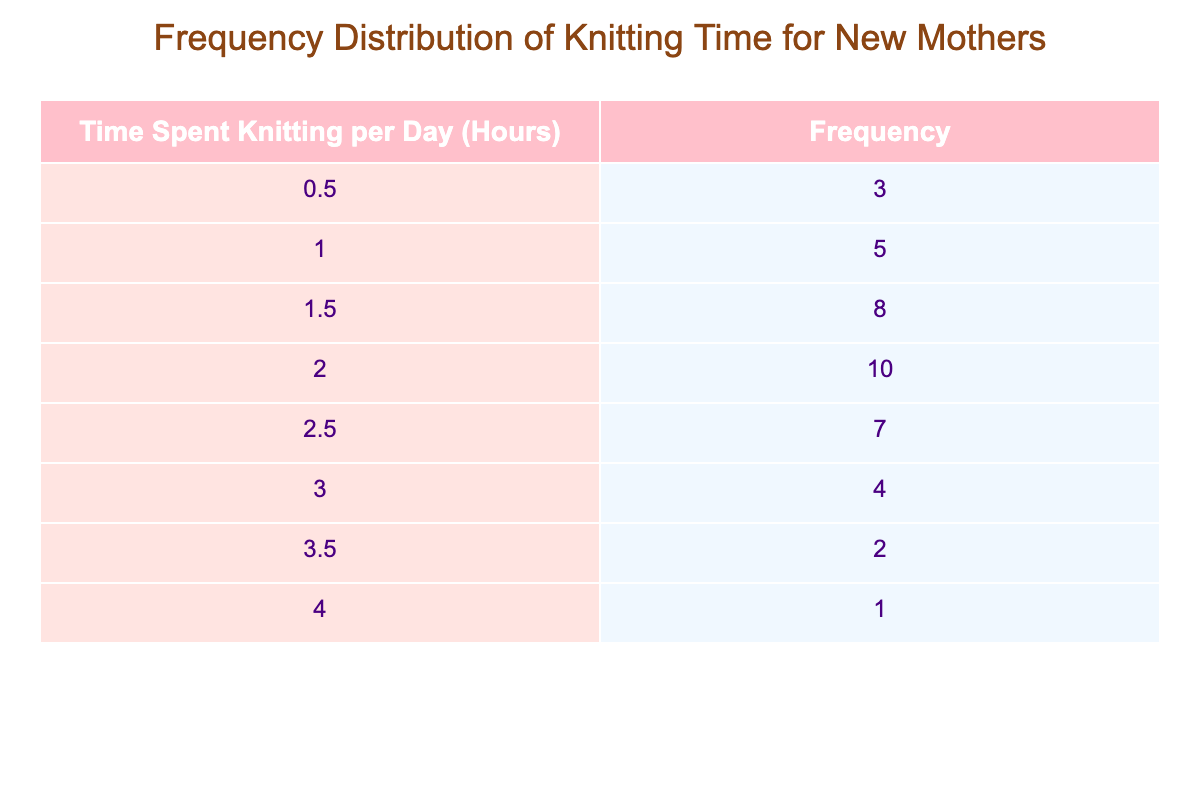What is the frequency of new mothers who spend 1 hour knitting each day? The table indicates that the frequency for 1 hour spent knitting per day is 5.
Answer: 5 How many new mothers spend less than 2 hours knitting per day? To find this, we add the frequencies for 0.5 hours and 1 hour (3 + 5) which equals 8, and for 1.5 hours, it's 8. So total frequency is 3 + 5 + 8 = 16.
Answer: 16 What is the most common amount of time spent knitting per day? The highest frequency in the table is for 2 hours with a frequency of 10.
Answer: 2 hours Is there anyone who knits for more than 4 hours each day? The table shows a frequency of 0 for 4.5 hours and there are no entries beyond 4 hours. Therefore, no one spends more than 4 hours knitting per day.
Answer: No What is the average time spent knitting per day among those who knit? To calculate the average, multiply each time spent by its frequency: (0.5 x 3) + (1 x 5) + (1.5 x 8) + (2 x 10) + (2.5 x 7) + (3 x 4) + (3.5 x 2) + (4 x 1) = 1.725 hours. Then divide by the total number of mothers (40): 68.0/40 = 1.7 hours.
Answer: 1.7 hours How many mothers spend 3 hours or more knitting each day? The frequencies for 3 hours, 3.5 hours, and 4 hours are 4, 2, and 1 respectively. Adding these gives 4 + 2 + 1 = 7 mothers who knit 3 hours or more daily.
Answer: 7 Which time category has the least number of new mothers knitting? The table indicates that the time category of 4 hours has the least frequency with only 1 mother.
Answer: 4 hours What percentage of mothers spend 2 hours or more knitting each day? First, find the total number of mothers: 40. Next, count those that knit for 2 hours or more: 10 (2 hours) + 7 (2.5 hours) + 4 (3 hours) + 2 (3.5 hours) + 1 (4 hours) = 24. Then calculate the percentage: (24/40) * 100 = 60%.
Answer: 60% 